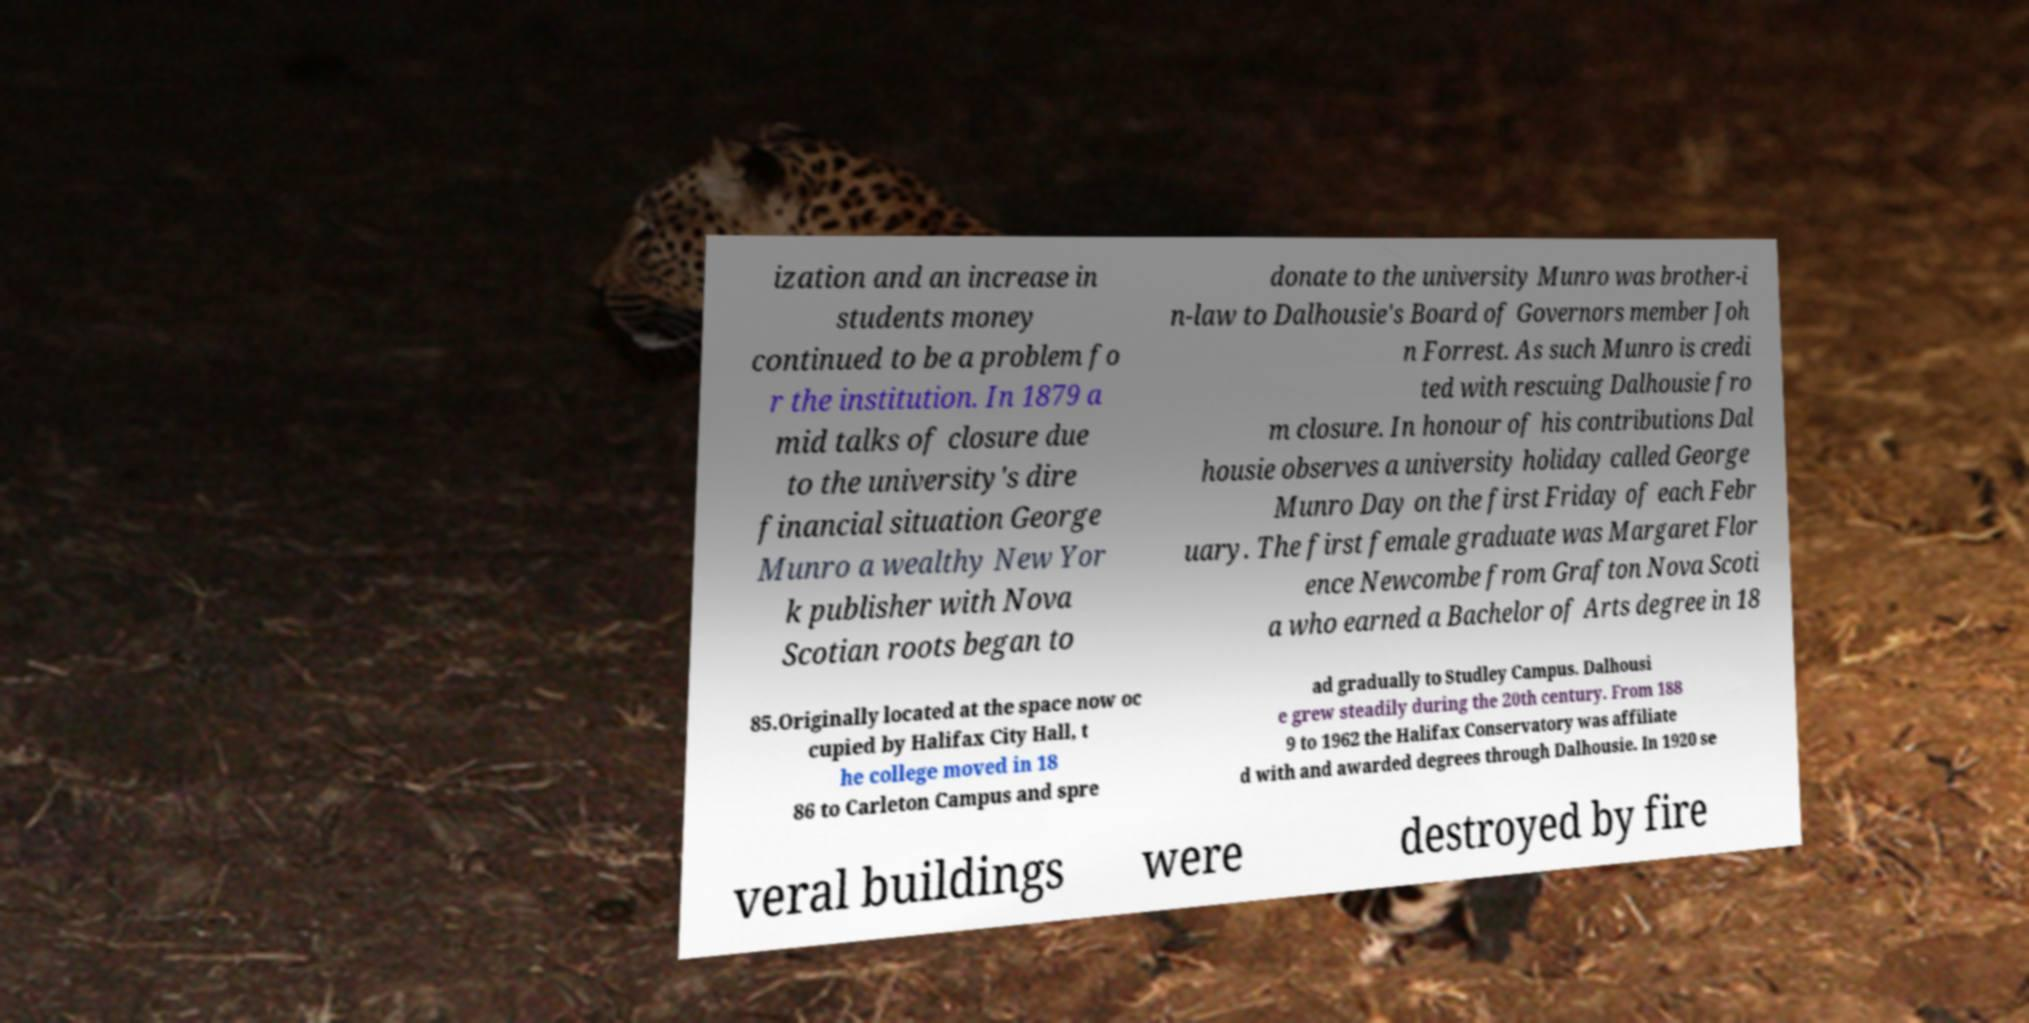There's text embedded in this image that I need extracted. Can you transcribe it verbatim? ization and an increase in students money continued to be a problem fo r the institution. In 1879 a mid talks of closure due to the university's dire financial situation George Munro a wealthy New Yor k publisher with Nova Scotian roots began to donate to the university Munro was brother-i n-law to Dalhousie's Board of Governors member Joh n Forrest. As such Munro is credi ted with rescuing Dalhousie fro m closure. In honour of his contributions Dal housie observes a university holiday called George Munro Day on the first Friday of each Febr uary. The first female graduate was Margaret Flor ence Newcombe from Grafton Nova Scoti a who earned a Bachelor of Arts degree in 18 85.Originally located at the space now oc cupied by Halifax City Hall, t he college moved in 18 86 to Carleton Campus and spre ad gradually to Studley Campus. Dalhousi e grew steadily during the 20th century. From 188 9 to 1962 the Halifax Conservatory was affiliate d with and awarded degrees through Dalhousie. In 1920 se veral buildings were destroyed by fire 